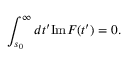<formula> <loc_0><loc_0><loc_500><loc_500>\int _ { s _ { 0 } } ^ { \infty } d t ^ { \prime } I m F ( t ^ { \prime } ) = 0 .</formula> 